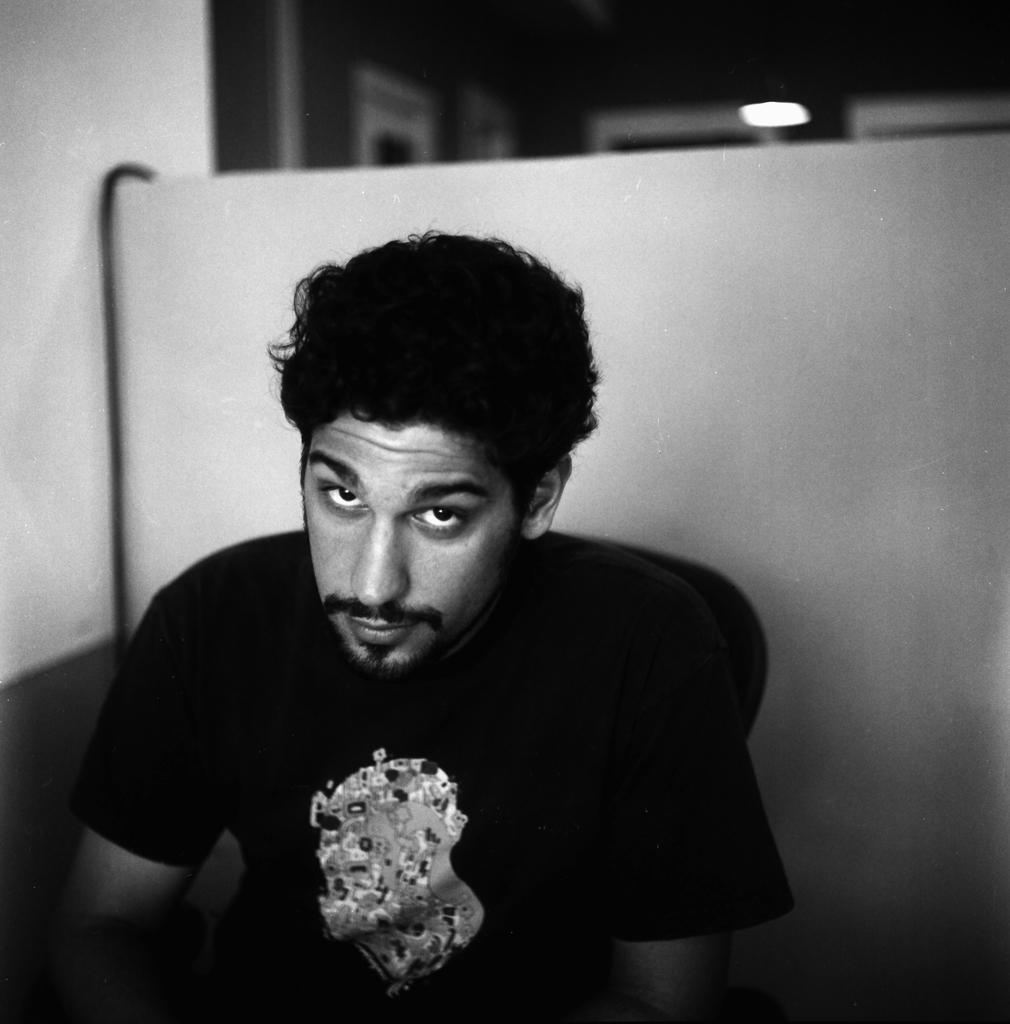In one or two sentences, can you explain what this image depicts? In this image I can see the person. In the background I can see the light and the image is in black and white. 